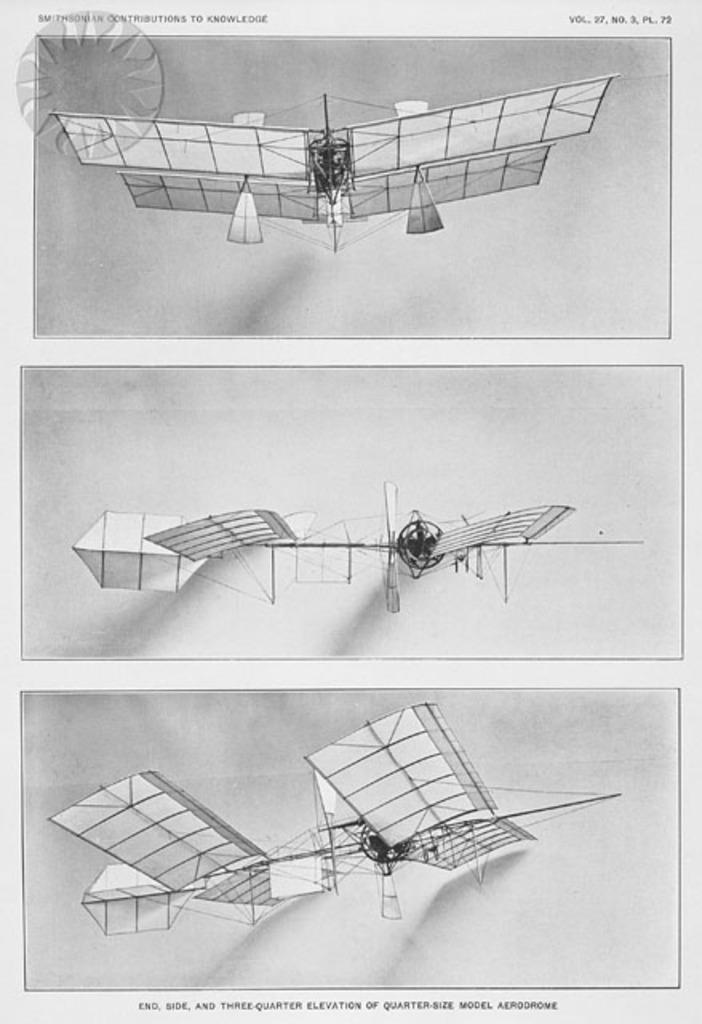<image>
Summarize the visual content of the image. An old drawing of a man powered flying machine published by the Smithsonian is shown. 